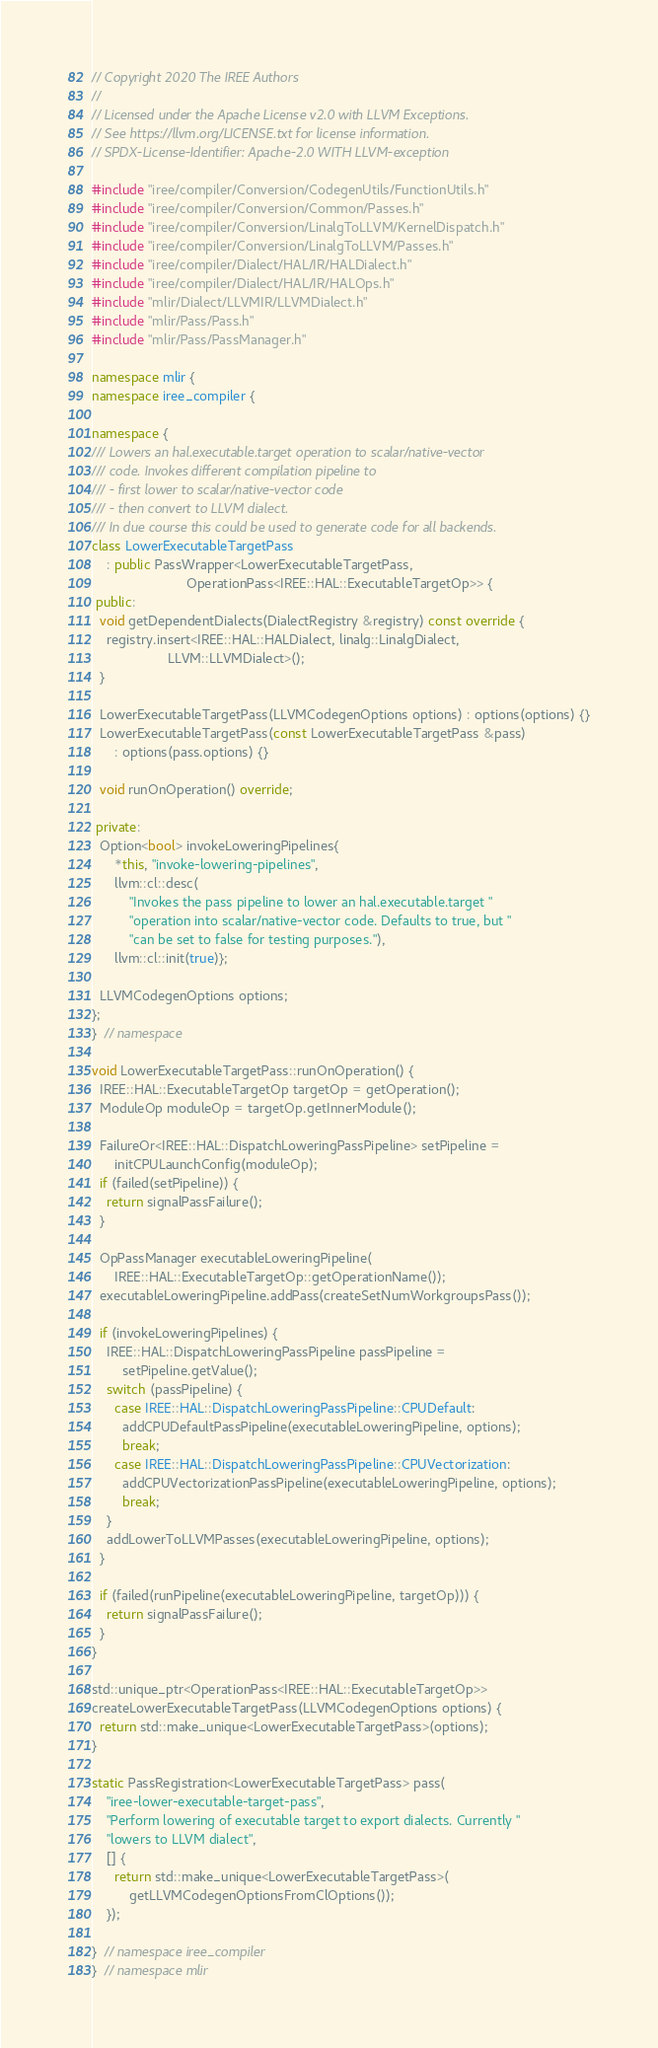<code> <loc_0><loc_0><loc_500><loc_500><_C++_>// Copyright 2020 The IREE Authors
//
// Licensed under the Apache License v2.0 with LLVM Exceptions.
// See https://llvm.org/LICENSE.txt for license information.
// SPDX-License-Identifier: Apache-2.0 WITH LLVM-exception

#include "iree/compiler/Conversion/CodegenUtils/FunctionUtils.h"
#include "iree/compiler/Conversion/Common/Passes.h"
#include "iree/compiler/Conversion/LinalgToLLVM/KernelDispatch.h"
#include "iree/compiler/Conversion/LinalgToLLVM/Passes.h"
#include "iree/compiler/Dialect/HAL/IR/HALDialect.h"
#include "iree/compiler/Dialect/HAL/IR/HALOps.h"
#include "mlir/Dialect/LLVMIR/LLVMDialect.h"
#include "mlir/Pass/Pass.h"
#include "mlir/Pass/PassManager.h"

namespace mlir {
namespace iree_compiler {

namespace {
/// Lowers an hal.executable.target operation to scalar/native-vector
/// code. Invokes different compilation pipeline to
/// - first lower to scalar/native-vector code
/// - then convert to LLVM dialect.
/// In due course this could be used to generate code for all backends.
class LowerExecutableTargetPass
    : public PassWrapper<LowerExecutableTargetPass,
                         OperationPass<IREE::HAL::ExecutableTargetOp>> {
 public:
  void getDependentDialects(DialectRegistry &registry) const override {
    registry.insert<IREE::HAL::HALDialect, linalg::LinalgDialect,
                    LLVM::LLVMDialect>();
  }

  LowerExecutableTargetPass(LLVMCodegenOptions options) : options(options) {}
  LowerExecutableTargetPass(const LowerExecutableTargetPass &pass)
      : options(pass.options) {}

  void runOnOperation() override;

 private:
  Option<bool> invokeLoweringPipelines{
      *this, "invoke-lowering-pipelines",
      llvm::cl::desc(
          "Invokes the pass pipeline to lower an hal.executable.target "
          "operation into scalar/native-vector code. Defaults to true, but "
          "can be set to false for testing purposes."),
      llvm::cl::init(true)};

  LLVMCodegenOptions options;
};
}  // namespace

void LowerExecutableTargetPass::runOnOperation() {
  IREE::HAL::ExecutableTargetOp targetOp = getOperation();
  ModuleOp moduleOp = targetOp.getInnerModule();

  FailureOr<IREE::HAL::DispatchLoweringPassPipeline> setPipeline =
      initCPULaunchConfig(moduleOp);
  if (failed(setPipeline)) {
    return signalPassFailure();
  }

  OpPassManager executableLoweringPipeline(
      IREE::HAL::ExecutableTargetOp::getOperationName());
  executableLoweringPipeline.addPass(createSetNumWorkgroupsPass());

  if (invokeLoweringPipelines) {
    IREE::HAL::DispatchLoweringPassPipeline passPipeline =
        setPipeline.getValue();
    switch (passPipeline) {
      case IREE::HAL::DispatchLoweringPassPipeline::CPUDefault:
        addCPUDefaultPassPipeline(executableLoweringPipeline, options);
        break;
      case IREE::HAL::DispatchLoweringPassPipeline::CPUVectorization:
        addCPUVectorizationPassPipeline(executableLoweringPipeline, options);
        break;
    }
    addLowerToLLVMPasses(executableLoweringPipeline, options);
  }

  if (failed(runPipeline(executableLoweringPipeline, targetOp))) {
    return signalPassFailure();
  }
}

std::unique_ptr<OperationPass<IREE::HAL::ExecutableTargetOp>>
createLowerExecutableTargetPass(LLVMCodegenOptions options) {
  return std::make_unique<LowerExecutableTargetPass>(options);
}

static PassRegistration<LowerExecutableTargetPass> pass(
    "iree-lower-executable-target-pass",
    "Perform lowering of executable target to export dialects. Currently "
    "lowers to LLVM dialect",
    [] {
      return std::make_unique<LowerExecutableTargetPass>(
          getLLVMCodegenOptionsFromClOptions());
    });

}  // namespace iree_compiler
}  // namespace mlir
</code> 